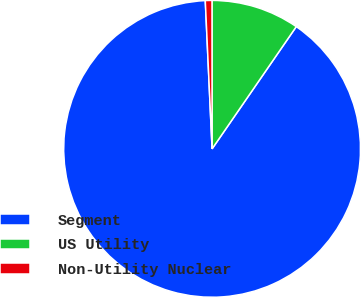Convert chart. <chart><loc_0><loc_0><loc_500><loc_500><pie_chart><fcel>Segment<fcel>US Utility<fcel>Non-Utility Nuclear<nl><fcel>89.67%<fcel>9.61%<fcel>0.72%<nl></chart> 